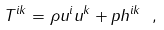Convert formula to latex. <formula><loc_0><loc_0><loc_500><loc_500>T ^ { i k } = \rho u ^ { i } u ^ { k } + p h ^ { i k } \ ,</formula> 